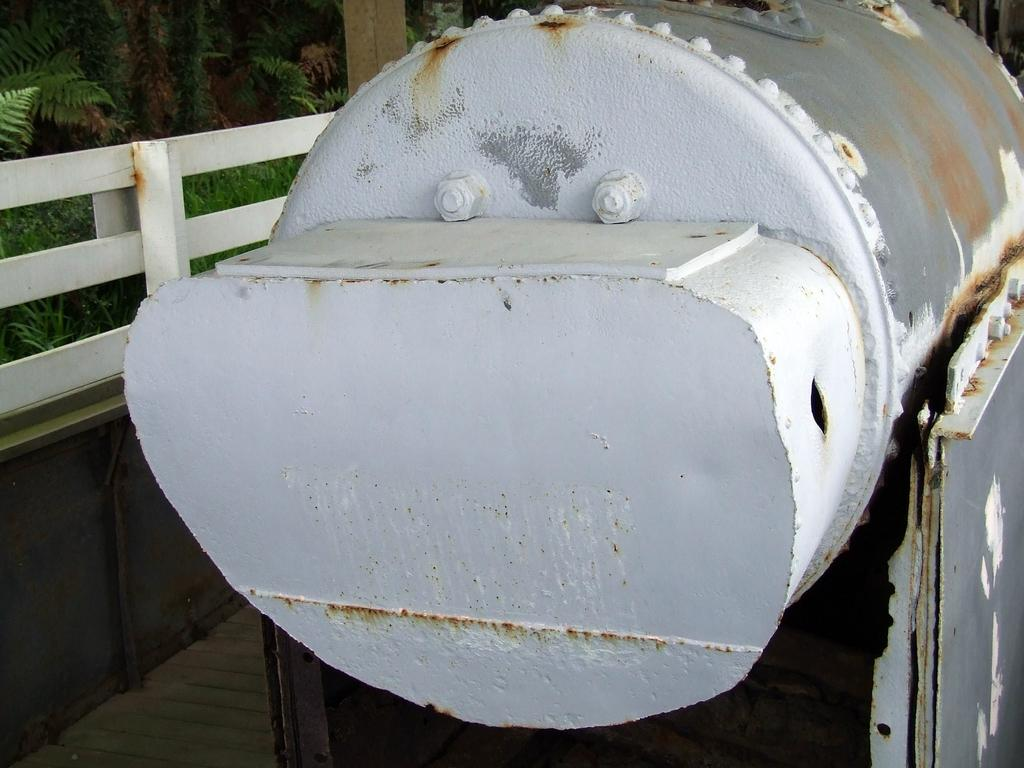What is the main object in the image? There is a white cylindrical metal object in the image. Can you describe the object in more detail? The object has nuts and bolts. What is located on the left side of the image? There is a white fence on the left side of the image. What can be seen behind the fence? There are trees behind the fence. What type of hope can be seen growing on the fence in the image? There is no hope growing on the fence in the image; it is a white fence with trees behind it. Can you see any ghosts interacting with the metal object in the image? There are no ghosts present in the image; it features a white cylindrical metal object with nuts and bolts, a white fence, and trees behind the fence. 